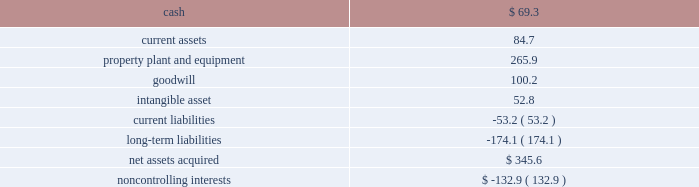Page 45 of 100 ball corporation and subsidiaries notes to consolidated financial statements 3 .
Acquisitions latapack-ball embalagens ltda .
( latapack-ball ) in august 2010 , the company paid $ 46.2 million to acquire an additional 10.1 percent economic interest in its brazilian beverage packaging joint venture , latapack-ball , through a transaction with the joint venture partner , latapack s.a .
This transaction increased the company 2019s overall economic interest in the joint venture to 60.1 percent and expands and strengthens ball 2019s presence in the growing brazilian market .
As a result of the transaction , latapack-ball became a variable interest entity ( vie ) under consolidation accounting guidelines with ball being identified as the primary beneficiary of the vie and consolidating the joint venture .
Latapack-ball operates metal beverage packaging manufacturing plants in tres rios , jacarei and salvador , brazil and has been included in the metal beverage packaging , americas and asia , reporting segment .
In connection with the acquisition , the company recorded a gain of $ 81.8 million on its previously held equity investment in latapack-ball as a result of required purchase accounting .
The table summarizes the final fair values of the latapack-ball assets acquired , liabilities assumed and non- controlling interest recognized , as well as the related investment in latapack s.a. , as of the acquisition date .
The valuation was based on market and income approaches. .
Noncontrolling interests $ ( 132.9 ) the customer relationships were identified as an intangible asset by the company and assigned an estimated life of 13.4 years .
The intangible asset is being amortized on a straight-line basis .
Neuman aluminum ( neuman ) in july 2010 , the company acquired neuman for approximately $ 62 million in cash .
Neuman had sales of approximately $ 128 million in 2009 ( unaudited ) and is the leading north american manufacturer of aluminum slugs used to make extruded aerosol cans , beverage bottles , aluminum collapsible tubes and technical impact extrusions .
Neuman operates two plants , one in the united states and one in canada , which employ approximately 180 people .
The acquisition of neuman is not material to the metal food and household products packaging , americas , segment , in which its results of operations have been included since the acquisition date .
Guangdong jianlibao group co. , ltd ( jianlibao ) in june 2010 , the company acquired jianlibao 2019s 65 percent interest in a joint venture metal beverage can and end plant in sanshui ( foshan ) , prc .
Ball has owned 35 percent of the joint venture plant since 1992 .
Ball acquired the 65 percent interest for $ 86.9 million in cash ( net of cash acquired ) and assumed debt , and also entered into a long-term supply agreement with jianlibao and one of its affiliates .
The company recorded equity earnings of $ 24.1 million , which was composed of equity earnings and a gain realized on the fair value of ball 2019s previous 35 percent equity investment as a result of required purchase accounting .
The purchase accounting was completed during the third quarter of 2010 .
The acquisition of the remaining interest is not material to the metal beverage packaging , americas and asia , segment. .
In june 2010 , what was the implied total value of the joint venture metal beverage can plant in the prc , in $ million? 
Computations: (86.9 / (65 / 100))
Answer: 133.69231. 